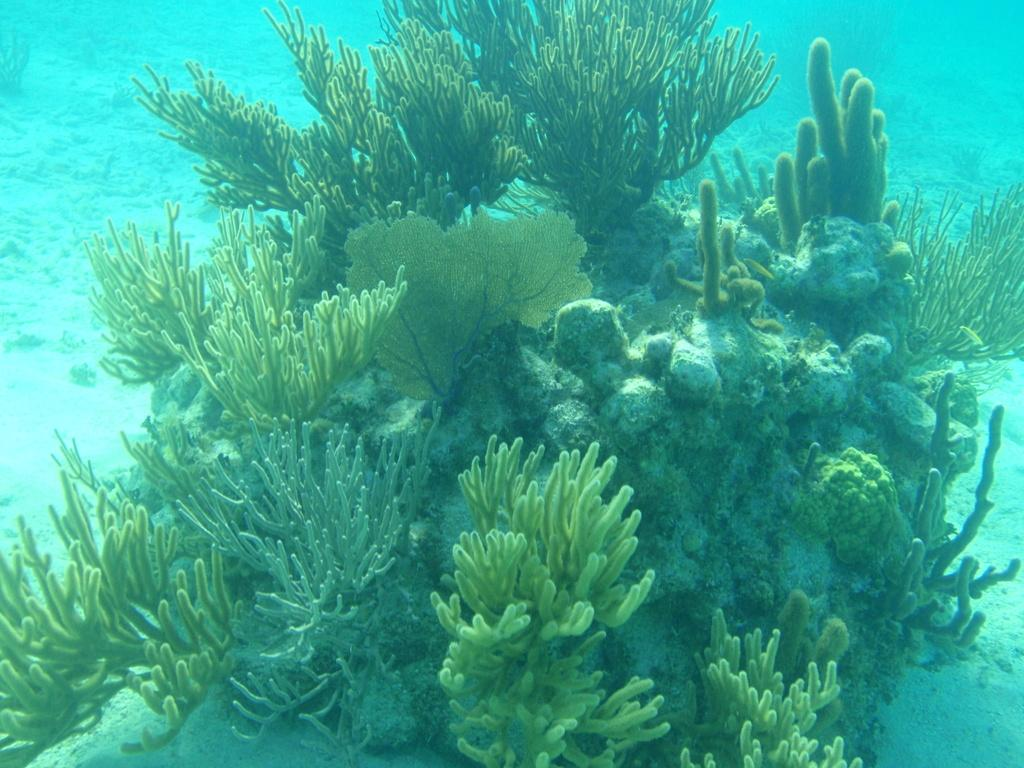What type of environment is depicted in the image? The image depicts an underwater environment. What can be found in this underwater environment? There are corals and plants in the image. Can you see a partner swimming alongside the corals in the image? There is no person or partner visible in the image; it only depicts an underwater environment with corals and plants. 